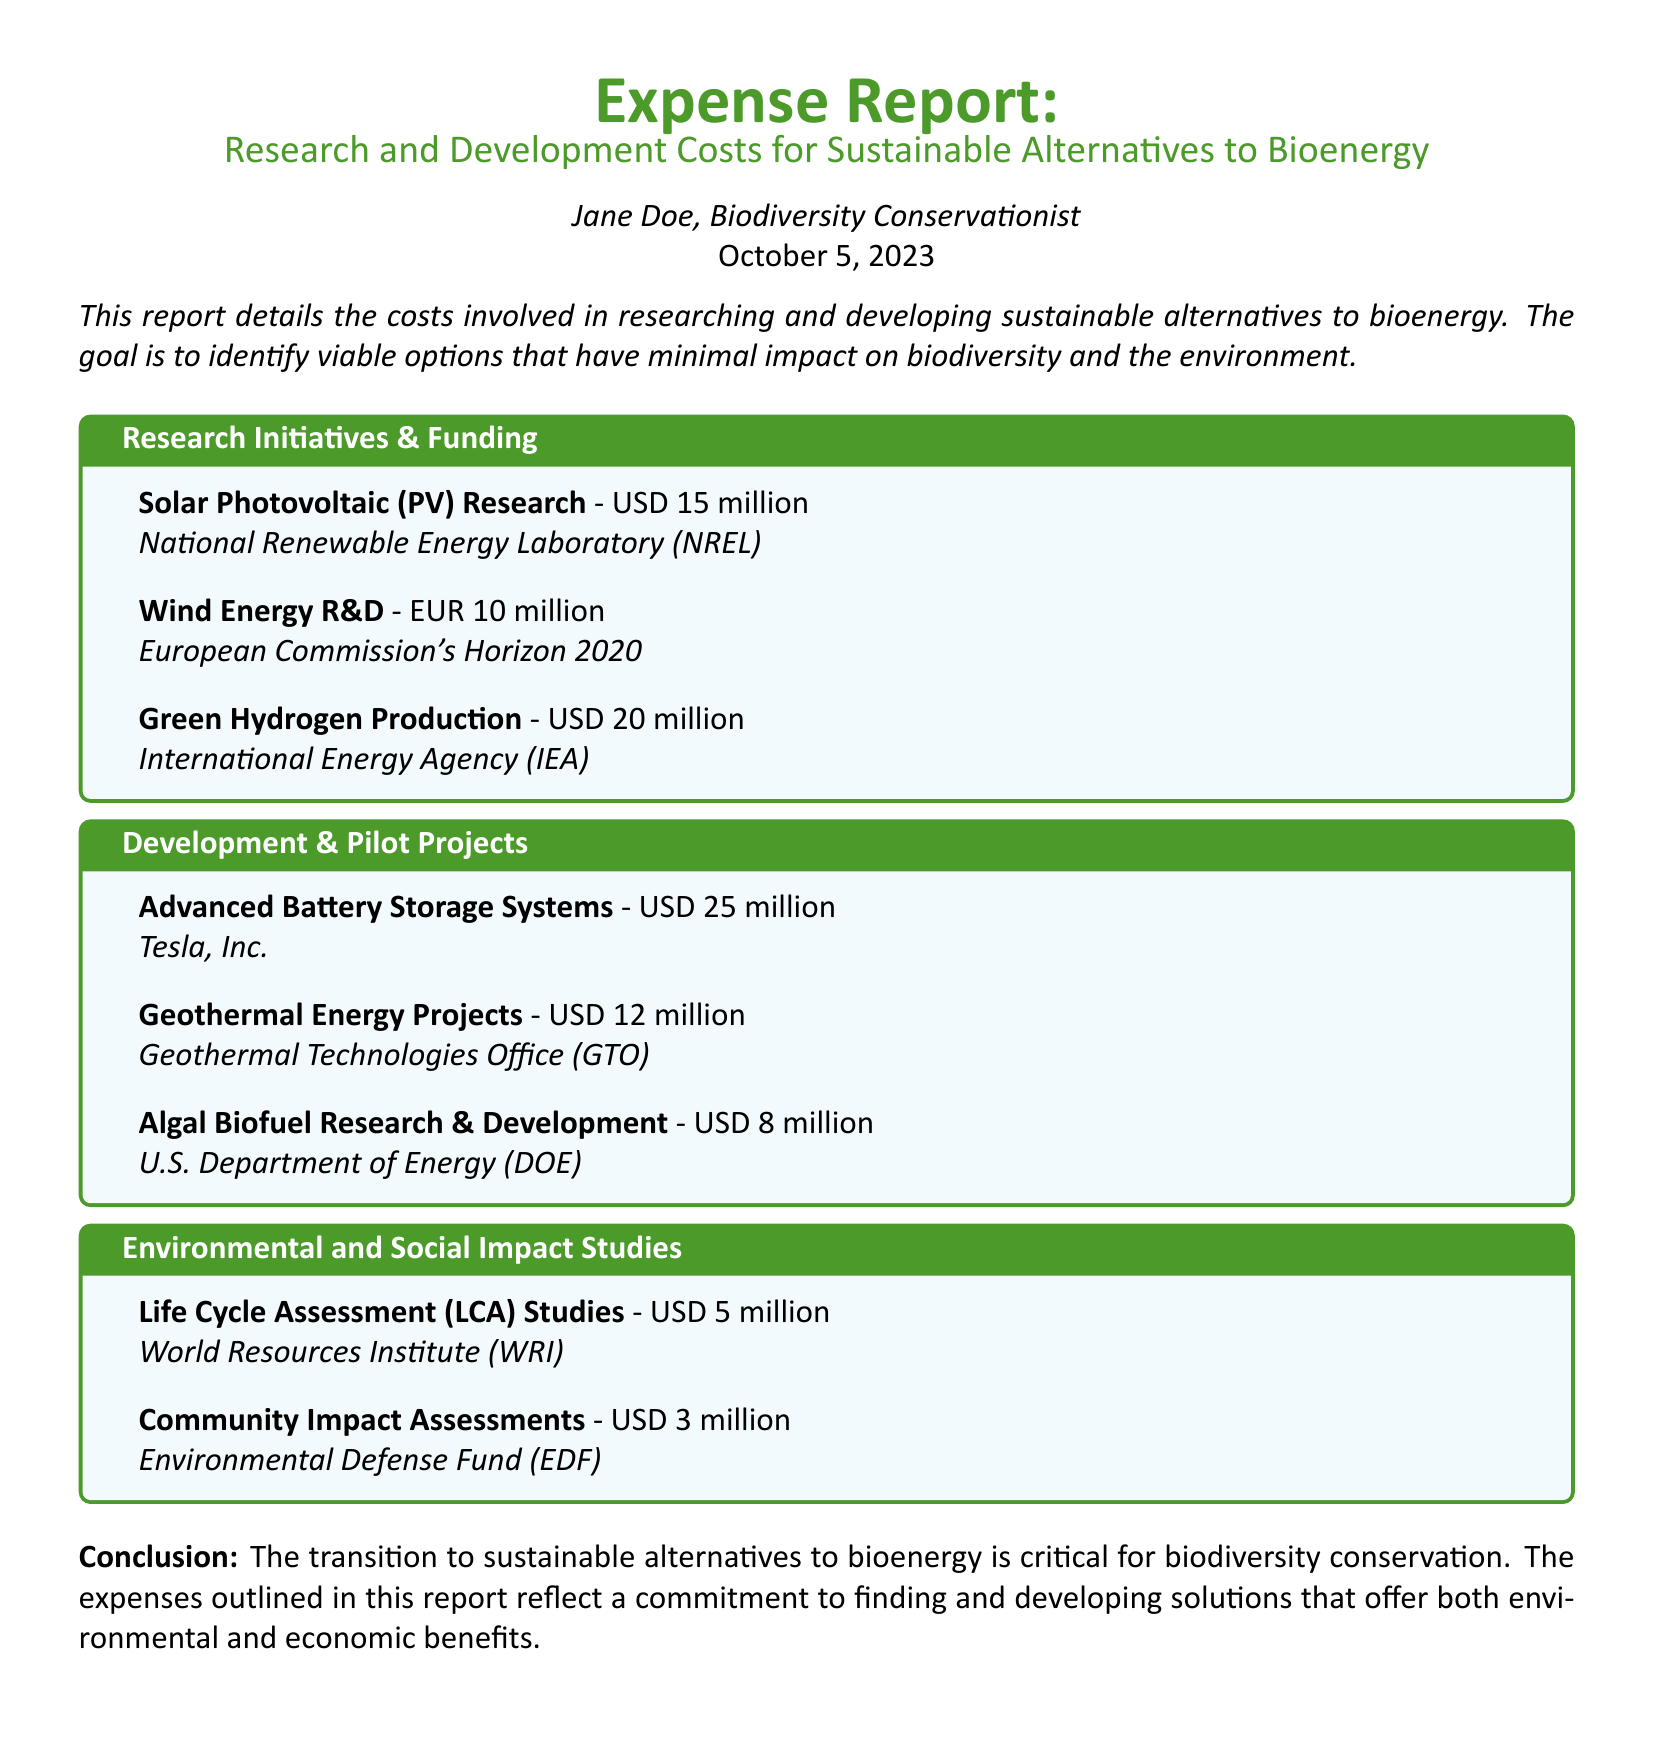What is the total amount allocated for Solar Photovoltaic Research? The document lists Solar Photovoltaic Research at USD 15 million.
Answer: USD 15 million Who funded the Wind Energy R&D? The funding for Wind Energy R&D is provided by the European Commission's Horizon 2020.
Answer: European Commission's Horizon 2020 How much funding is allocated for Green Hydrogen Production? The document states that Green Hydrogen Production has a funding of USD 20 million.
Answer: USD 20 million What is the cost of the Advanced Battery Storage Systems project? Advanced Battery Storage Systems is reported to cost USD 25 million.
Answer: USD 25 million Which organization conducted the Life Cycle Assessment Studies? The Life Cycle Assessment Studies are conducted by the World Resources Institute.
Answer: World Resources Institute What is the total expense amount for Development & Pilot Projects? The total expenses for Development & Pilot Projects combine to USD 45 million, derived from individual project costs.
Answer: USD 45 million Which impact assessments are mentioned in the Environmental and Social Impact Studies section? The document cites Life Cycle Assessment Studies and Community Impact Assessments.
Answer: Life Cycle Assessment Studies and Community Impact Assessments What is the purpose of this expense report? The report aims to detail costs associated with researching and developing sustainable alternatives to bioenergy.
Answer: Researching and developing sustainable alternatives to bioenergy How much was spent on Community Impact Assessments? Community Impact Assessments cost USD 3 million according to the document.
Answer: USD 3 million 